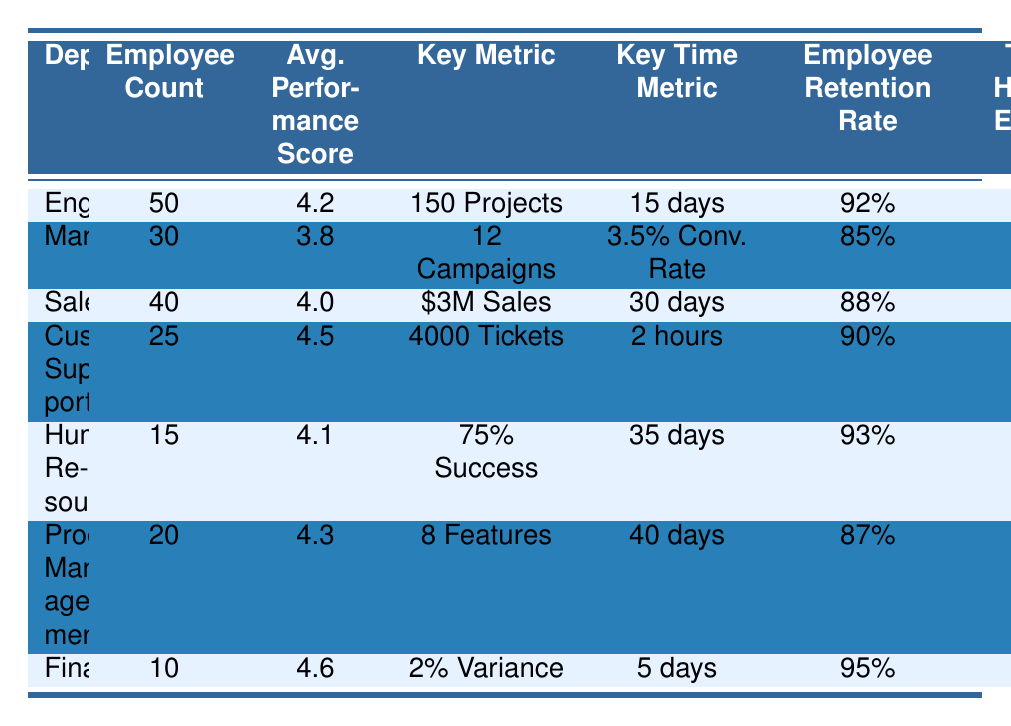What is the average performance score for the Engineering department? The table shows that the Engineering department has an average performance score of 4.2.
Answer: 4.2 Which department has the highest employee retention rate? By comparing the employee retention rates listed, Finance has the highest rate at 95%.
Answer: Finance How many training hours per employee are provided in Customer Support? The table indicates that Customer Support provides 10 training hours per employee.
Answer: 10 What is the average time to complete a project in the Engineering department? The average time to complete a project in Engineering is listed as 15 days in the table.
Answer: 15 days What is the total employee count across all departments? The total employee count is calculated by adding the employees from all departments: 50 + 30 + 40 + 25 + 15 + 20 + 10 = 190.
Answer: 190 Is the average performance score for the Marketing department above 4.0? The table lists the average performance score for Marketing as 3.8, which is below 4.0.
Answer: No How many campaigns has the Marketing department launched in 2023? The Marketing department has launched a total of 12 campaigns according to the table.
Answer: 12 What is the difference in employee retention rates between Sales and Customer Support? The employee retention rate for Sales is 88%, and for Customer Support, it is 90%. The difference is 90% - 88% = 2%.
Answer: 2% What is the employee count for the Product Management department? The Product Management department has an employee count of 20 as mentioned in the table.
Answer: 20 Which department has the lowest average performance score? Comparing average performance scores, Marketing has the lowest score at 3.8.
Answer: Marketing Are there more training hours per employee in Finance than in Human Resources? Finance provides 14 hours and Human Resources provides 12 hours, so yes, Finance has more training hours per employee.
Answer: Yes What average development cycle time is reported for Product Management? The table states that the average development cycle time for Product Management is 40 days.
Answer: 40 days Which department resolved the highest number of tickets in 2023? The Customer Support department resolved 4000 tickets, which is the highest among all.
Answer: Customer Support If we average the employee retention rates, what would be the result? Adding the rates (92% + 85% + 88% + 90% + 93% + 87% + 95% = 620%) and dividing by 7 gives an average retention rate of approximately 88.57%.
Answer: 88.57% Which department has completed more projects, Engineering or Product Management? Engineering completed 150 projects whereas Product Management completed 8, so Engineering has completed more.
Answer: Engineering What is the average sales volume reported by the Sales department? The Sales department's average sales volume is reported as $3 million in the table.
Answer: $3 million 